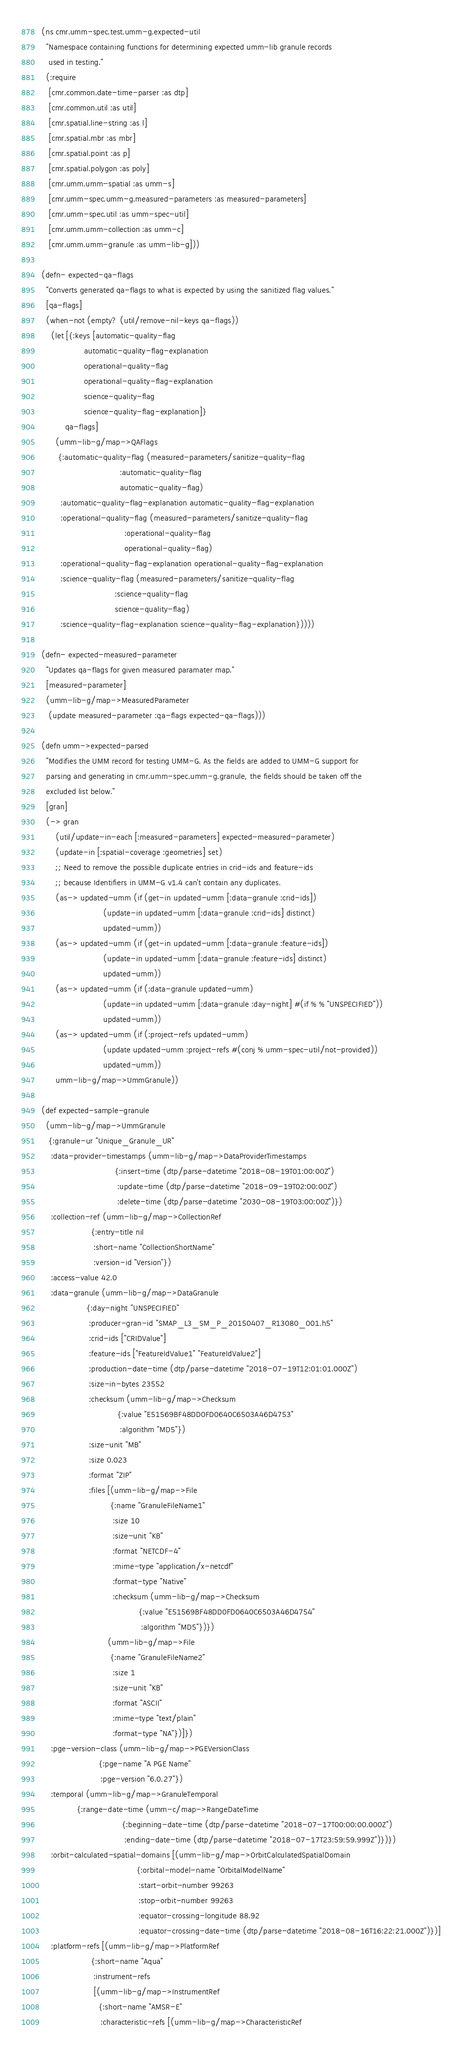<code> <loc_0><loc_0><loc_500><loc_500><_Clojure_>(ns cmr.umm-spec.test.umm-g.expected-util
  "Namespace containing functions for determining expected umm-lib granule records
   used in testing."
  (:require
   [cmr.common.date-time-parser :as dtp]
   [cmr.common.util :as util]
   [cmr.spatial.line-string :as l]
   [cmr.spatial.mbr :as mbr]
   [cmr.spatial.point :as p]
   [cmr.spatial.polygon :as poly]
   [cmr.umm.umm-spatial :as umm-s]
   [cmr.umm-spec.umm-g.measured-parameters :as measured-parameters]
   [cmr.umm-spec.util :as umm-spec-util]
   [cmr.umm.umm-collection :as umm-c]
   [cmr.umm.umm-granule :as umm-lib-g]))

(defn- expected-qa-flags
  "Converts generated qa-flags to what is expected by using the sanitized flag values."
  [qa-flags]
  (when-not (empty? (util/remove-nil-keys qa-flags))
    (let [{:keys [automatic-quality-flag
                  automatic-quality-flag-explanation
                  operational-quality-flag
                  operational-quality-flag-explanation
                  science-quality-flag
                  science-quality-flag-explanation]}
          qa-flags]
      (umm-lib-g/map->QAFlags
       {:automatic-quality-flag (measured-parameters/sanitize-quality-flag
                                 :automatic-quality-flag
                                 automatic-quality-flag)
        :automatic-quality-flag-explanation automatic-quality-flag-explanation
        :operational-quality-flag (measured-parameters/sanitize-quality-flag
                                   :operational-quality-flag
                                   operational-quality-flag)
        :operational-quality-flag-explanation operational-quality-flag-explanation
        :science-quality-flag (measured-parameters/sanitize-quality-flag
                               :science-quality-flag
                               science-quality-flag)
        :science-quality-flag-explanation science-quality-flag-explanation}))))

(defn- expected-measured-parameter
  "Updates qa-flags for given measured paramater map."
  [measured-parameter]
  (umm-lib-g/map->MeasuredParameter
   (update measured-parameter :qa-flags expected-qa-flags)))

(defn umm->expected-parsed
  "Modifies the UMM record for testing UMM-G. As the fields are added to UMM-G support for
  parsing and generating in cmr.umm-spec.umm-g.granule, the fields should be taken off the
  excluded list below."
  [gran]
  (-> gran
      (util/update-in-each [:measured-parameters] expected-measured-parameter)
      (update-in [:spatial-coverage :geometries] set)
      ;; Need to remove the possible duplicate entries in crid-ids and feature-ids
      ;; because Identifiers in UMM-G v1.4 can't contain any duplicates.
      (as-> updated-umm (if (get-in updated-umm [:data-granule :crid-ids])
                          (update-in updated-umm [:data-granule :crid-ids] distinct)
                          updated-umm))
      (as-> updated-umm (if (get-in updated-umm [:data-granule :feature-ids])
                          (update-in updated-umm [:data-granule :feature-ids] distinct)
                          updated-umm))
      (as-> updated-umm (if (:data-granule updated-umm)
                          (update-in updated-umm [:data-granule :day-night] #(if % % "UNSPECIFIED"))
                          updated-umm))
      (as-> updated-umm (if (:project-refs updated-umm)
                          (update updated-umm :project-refs #(conj % umm-spec-util/not-provided))
                          updated-umm))
      umm-lib-g/map->UmmGranule))

(def expected-sample-granule
  (umm-lib-g/map->UmmGranule
   {:granule-ur "Unique_Granule_UR"
    :data-provider-timestamps (umm-lib-g/map->DataProviderTimestamps
                               {:insert-time (dtp/parse-datetime "2018-08-19T01:00:00Z")
                                :update-time (dtp/parse-datetime "2018-09-19T02:00:00Z")
                                :delete-time (dtp/parse-datetime "2030-08-19T03:00:00Z")})
    :collection-ref (umm-lib-g/map->CollectionRef
                     {:entry-title nil
                      :short-name "CollectionShortName"
                      :version-id "Version"})
    :access-value 42.0
    :data-granule (umm-lib-g/map->DataGranule
                   {:day-night "UNSPECIFIED"
                    :producer-gran-id "SMAP_L3_SM_P_20150407_R13080_001.h5"
                    :crid-ids ["CRIDValue"]
                    :feature-ids ["FeatureIdValue1" "FeatureIdValue2"]
                    :production-date-time (dtp/parse-datetime "2018-07-19T12:01:01.000Z")
                    :size-in-bytes 23552
                    :checksum (umm-lib-g/map->Checksum
                                {:value "E51569BF48DD0FD0640C6503A46D4753"
                                 :algorithm "MD5"})
                    :size-unit "MB"
                    :size 0.023
                    :format "ZIP"
                    :files [(umm-lib-g/map->File
                             {:name "GranuleFileName1"
                              :size 10
                              :size-unit "KB"
                              :format "NETCDF-4"
                              :mime-type "application/x-netcdf"
                              :format-type "Native"
                              :checksum (umm-lib-g/map->Checksum
                                         {:value "E51569BF48DD0FD0640C6503A46D4754"
                                          :algorithm "MD5"})})
                            (umm-lib-g/map->File
                             {:name "GranuleFileName2"
                              :size 1
                              :size-unit "KB"
                              :format "ASCII"
                              :mime-type "text/plain"
                              :format-type "NA"})]})
    :pge-version-class (umm-lib-g/map->PGEVersionClass
                        {:pge-name "A PGE Name"
                         :pge-version "6.0.27"})
    :temporal (umm-lib-g/map->GranuleTemporal
               {:range-date-time (umm-c/map->RangeDateTime
                                  {:beginning-date-time (dtp/parse-datetime "2018-07-17T00:00:00.000Z")
                                   :ending-date-time (dtp/parse-datetime "2018-07-17T23:59:59.999Z")})})
    :orbit-calculated-spatial-domains [(umm-lib-g/map->OrbitCalculatedSpatialDomain
                                        {:orbital-model-name "OrbitalModelName"
                                         :start-orbit-number 99263
                                         :stop-orbit-number 99263
                                         :equator-crossing-longitude 88.92
                                         :equator-crossing-date-time (dtp/parse-datetime "2018-08-16T16:22:21.000Z")})]
    :platform-refs [(umm-lib-g/map->PlatformRef
                     {:short-name "Aqua"
                      :instrument-refs
                      [(umm-lib-g/map->InstrumentRef
                        {:short-name "AMSR-E"
                         :characteristic-refs [(umm-lib-g/map->CharacteristicRef</code> 